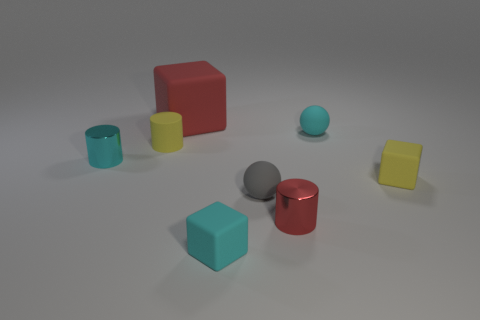Subtract 1 cylinders. How many cylinders are left? 2 Subtract all tiny cubes. How many cubes are left? 1 Add 2 red cylinders. How many objects exist? 10 Subtract 1 cyan cylinders. How many objects are left? 7 Subtract all spheres. How many objects are left? 6 Subtract all brown metal blocks. Subtract all tiny yellow matte cylinders. How many objects are left? 7 Add 1 small gray matte things. How many small gray matte things are left? 2 Add 6 red matte cubes. How many red matte cubes exist? 7 